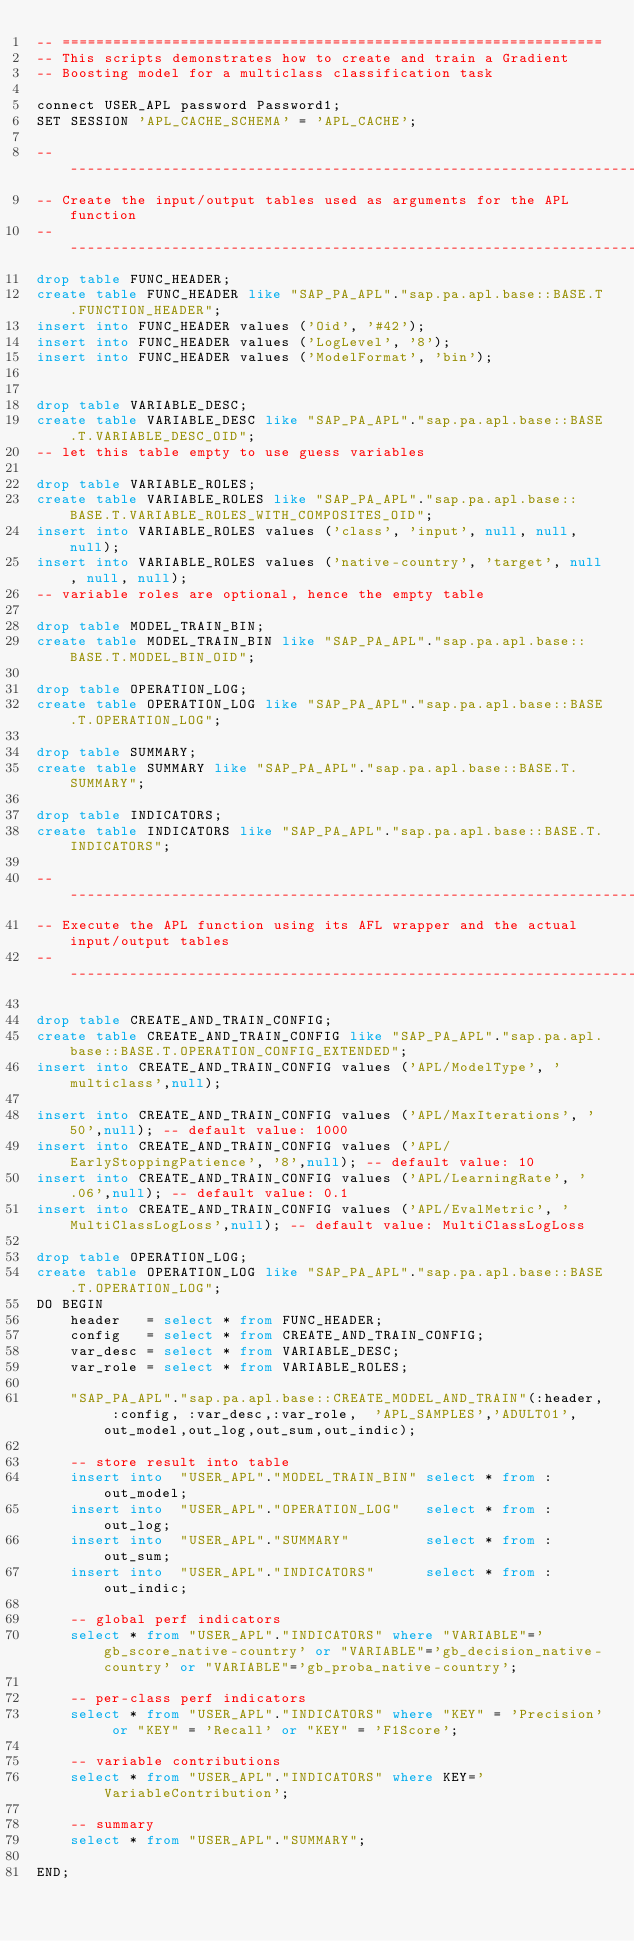<code> <loc_0><loc_0><loc_500><loc_500><_SQL_>-- ================================================================
-- This scripts demonstrates how to create and train a Gradient
-- Boosting model for a multiclass classification task

connect USER_APL password Password1;
SET SESSION 'APL_CACHE_SCHEMA' = 'APL_CACHE';

-- --------------------------------------------------------------------------
-- Create the input/output tables used as arguments for the APL function
-- --------------------------------------------------------------------------
drop table FUNC_HEADER;
create table FUNC_HEADER like "SAP_PA_APL"."sap.pa.apl.base::BASE.T.FUNCTION_HEADER";
insert into FUNC_HEADER values ('Oid', '#42');
insert into FUNC_HEADER values ('LogLevel', '8');
insert into FUNC_HEADER values ('ModelFormat', 'bin');


drop table VARIABLE_DESC;
create table VARIABLE_DESC like "SAP_PA_APL"."sap.pa.apl.base::BASE.T.VARIABLE_DESC_OID";
-- let this table empty to use guess variables

drop table VARIABLE_ROLES;
create table VARIABLE_ROLES like "SAP_PA_APL"."sap.pa.apl.base::BASE.T.VARIABLE_ROLES_WITH_COMPOSITES_OID";
insert into VARIABLE_ROLES values ('class', 'input', null, null, null);
insert into VARIABLE_ROLES values ('native-country', 'target', null, null, null);
-- variable roles are optional, hence the empty table

drop table MODEL_TRAIN_BIN;
create table MODEL_TRAIN_BIN like "SAP_PA_APL"."sap.pa.apl.base::BASE.T.MODEL_BIN_OID";

drop table OPERATION_LOG;
create table OPERATION_LOG like "SAP_PA_APL"."sap.pa.apl.base::BASE.T.OPERATION_LOG";

drop table SUMMARY;
create table SUMMARY like "SAP_PA_APL"."sap.pa.apl.base::BASE.T.SUMMARY";

drop table INDICATORS;
create table INDICATORS like "SAP_PA_APL"."sap.pa.apl.base::BASE.T.INDICATORS";

-- --------------------------------------------------------------------------
-- Execute the APL function using its AFL wrapper and the actual input/output tables
-- --------------------------------------------------------------------------

drop table CREATE_AND_TRAIN_CONFIG;
create table CREATE_AND_TRAIN_CONFIG like "SAP_PA_APL"."sap.pa.apl.base::BASE.T.OPERATION_CONFIG_EXTENDED";
insert into CREATE_AND_TRAIN_CONFIG values ('APL/ModelType', 'multiclass',null);

insert into CREATE_AND_TRAIN_CONFIG values ('APL/MaxIterations', '50',null); -- default value: 1000
insert into CREATE_AND_TRAIN_CONFIG values ('APL/EarlyStoppingPatience', '8',null); -- default value: 10
insert into CREATE_AND_TRAIN_CONFIG values ('APL/LearningRate', '.06',null); -- default value: 0.1
insert into CREATE_AND_TRAIN_CONFIG values ('APL/EvalMetric', 'MultiClassLogLoss',null); -- default value: MultiClassLogLoss

drop table OPERATION_LOG;
create table OPERATION_LOG like "SAP_PA_APL"."sap.pa.apl.base::BASE.T.OPERATION_LOG";
DO BEGIN     
    header   = select * from FUNC_HEADER;             
    config   = select * from CREATE_AND_TRAIN_CONFIG;            
    var_desc = select * from VARIABLE_DESC;              
    var_role = select * from VARIABLE_ROLES;  

    "SAP_PA_APL"."sap.pa.apl.base::CREATE_MODEL_AND_TRAIN"(:header, :config, :var_desc,:var_role,  'APL_SAMPLES','ADULT01',out_model,out_log,out_sum,out_indic);
    
    -- store result into table
    insert into  "USER_APL"."MODEL_TRAIN_BIN" select * from :out_model;
    insert into  "USER_APL"."OPERATION_LOG"   select * from :out_log;
    insert into  "USER_APL"."SUMMARY"         select * from :out_sum;
    insert into  "USER_APL"."INDICATORS"      select * from :out_indic;

    -- global perf indicators
    select * from "USER_APL"."INDICATORS" where "VARIABLE"='gb_score_native-country' or "VARIABLE"='gb_decision_native-country' or "VARIABLE"='gb_proba_native-country';

    -- per-class perf indicators
    select * from "USER_APL"."INDICATORS" where "KEY" = 'Precision' or "KEY" = 'Recall' or "KEY" = 'F1Score';

    -- variable contributions
    select * from "USER_APL"."INDICATORS" where KEY='VariableContribution';

    -- summary
    select * from "USER_APL"."SUMMARY";

END;</code> 